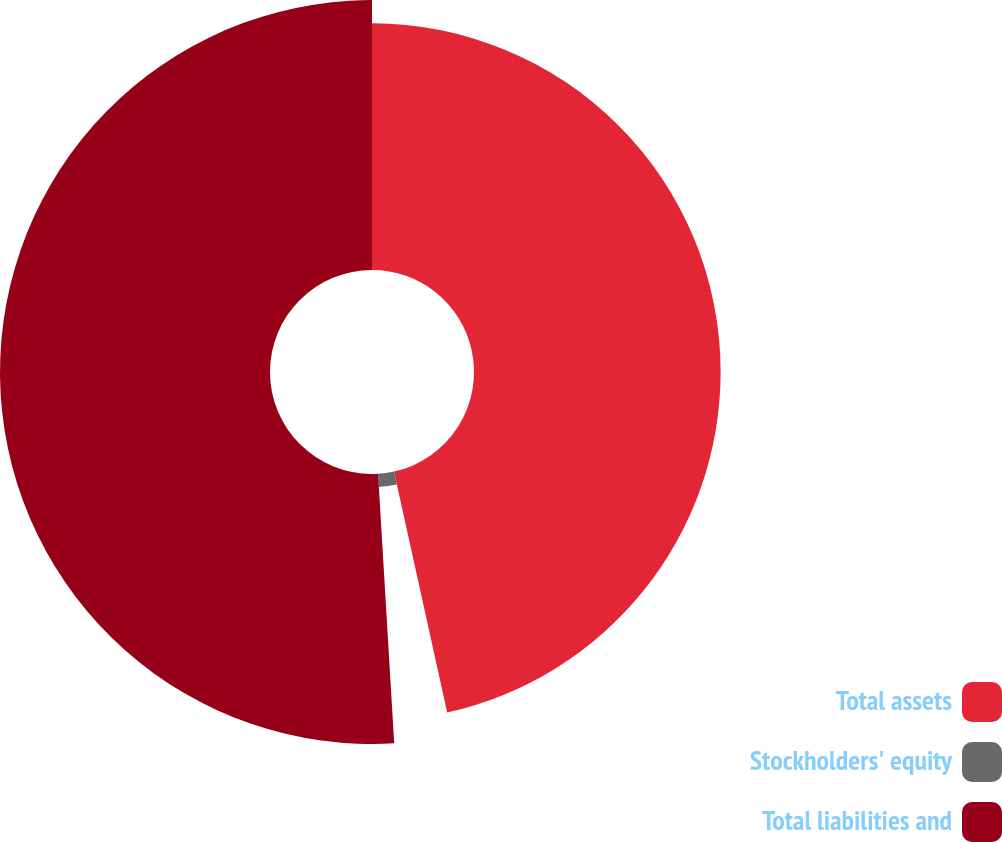Convert chart to OTSL. <chart><loc_0><loc_0><loc_500><loc_500><pie_chart><fcel>Total assets<fcel>Stockholders' equity<fcel>Total liabilities and<nl><fcel>46.54%<fcel>2.51%<fcel>50.95%<nl></chart> 